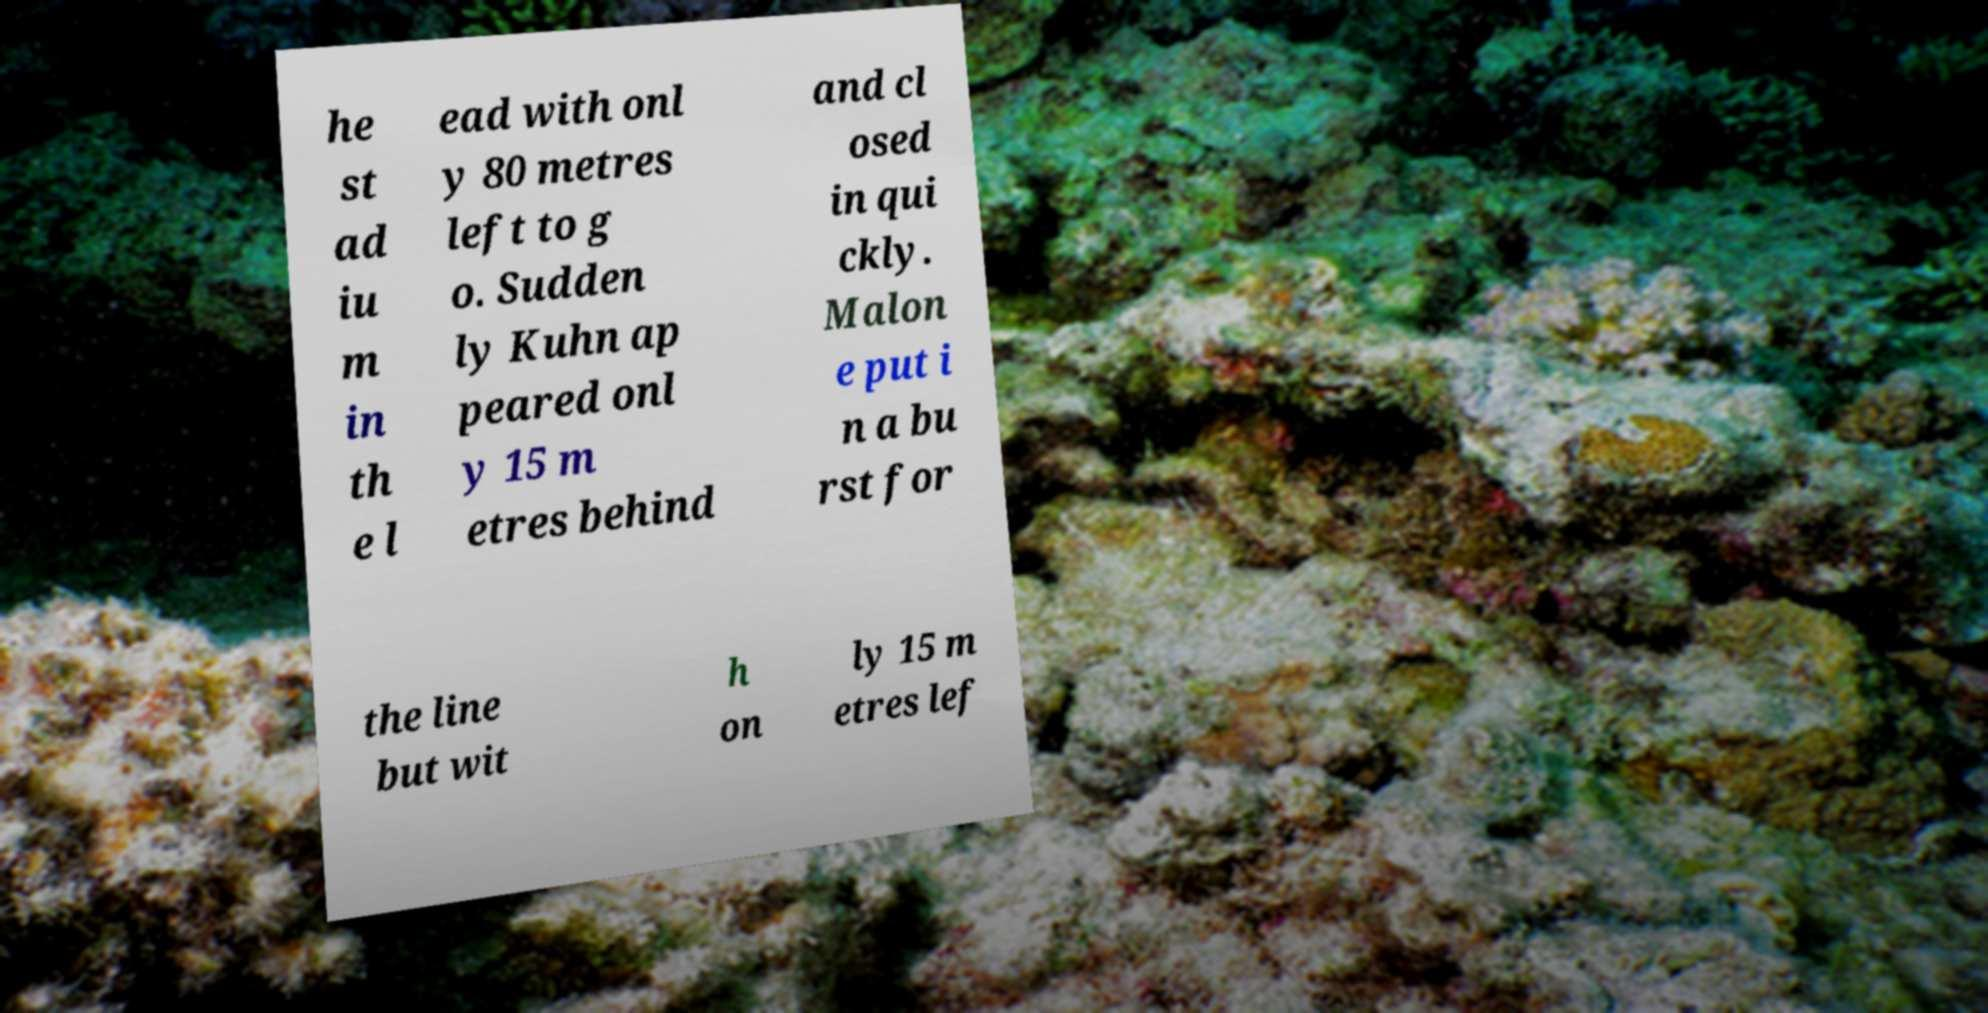Can you accurately transcribe the text from the provided image for me? he st ad iu m in th e l ead with onl y 80 metres left to g o. Sudden ly Kuhn ap peared onl y 15 m etres behind and cl osed in qui ckly. Malon e put i n a bu rst for the line but wit h on ly 15 m etres lef 